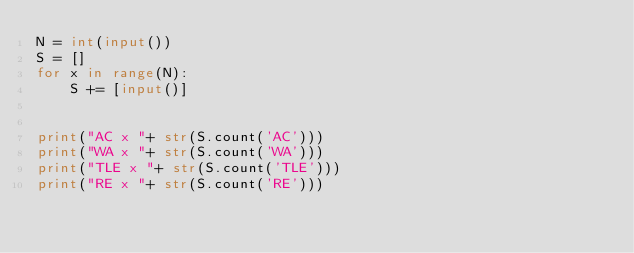Convert code to text. <code><loc_0><loc_0><loc_500><loc_500><_Python_>N = int(input())
S = []
for x in range(N):
    S += [input()]


print("AC x "+ str(S.count('AC')))
print("WA x "+ str(S.count('WA')))
print("TLE x "+ str(S.count('TLE')))
print("RE x "+ str(S.count('RE')))</code> 